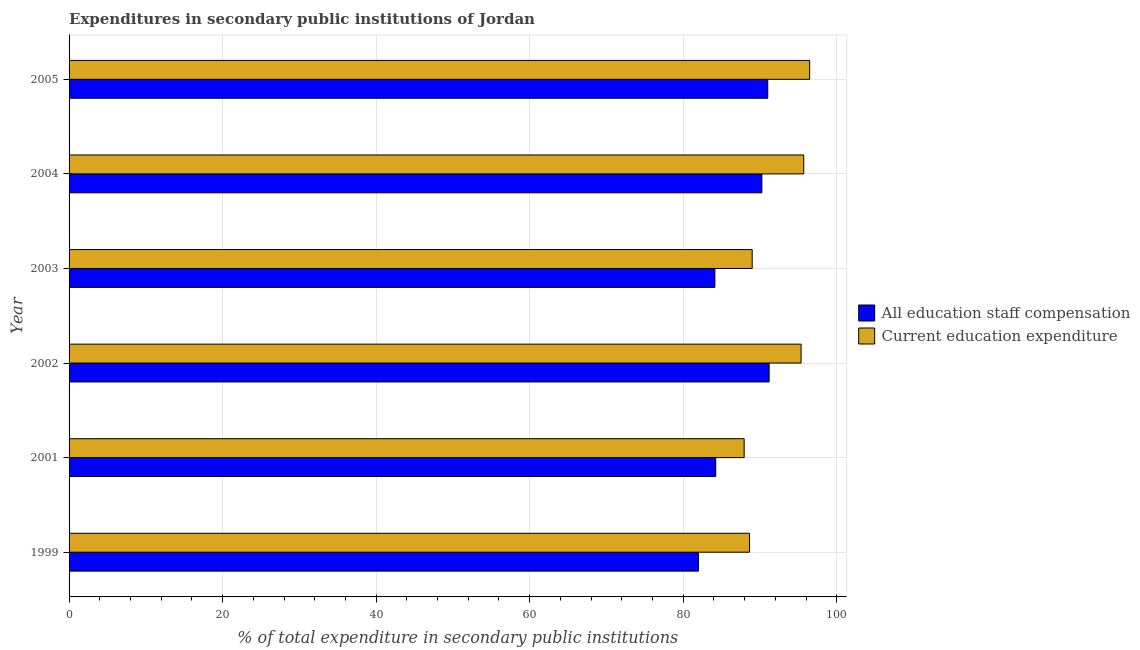How many different coloured bars are there?
Make the answer very short. 2. Are the number of bars on each tick of the Y-axis equal?
Provide a short and direct response. Yes. How many bars are there on the 3rd tick from the bottom?
Offer a very short reply. 2. What is the label of the 1st group of bars from the top?
Ensure brevity in your answer.  2005. In how many cases, is the number of bars for a given year not equal to the number of legend labels?
Offer a terse response. 0. What is the expenditure in staff compensation in 2001?
Your answer should be very brief. 84.24. Across all years, what is the maximum expenditure in staff compensation?
Offer a very short reply. 91.19. Across all years, what is the minimum expenditure in staff compensation?
Offer a very short reply. 81.99. In which year was the expenditure in education minimum?
Make the answer very short. 2001. What is the total expenditure in education in the graph?
Your response must be concise. 553.09. What is the difference between the expenditure in education in 2002 and that in 2003?
Your response must be concise. 6.37. What is the difference between the expenditure in education in 2003 and the expenditure in staff compensation in 2001?
Keep it short and to the point. 4.75. What is the average expenditure in staff compensation per year?
Make the answer very short. 87.13. In the year 2002, what is the difference between the expenditure in education and expenditure in staff compensation?
Your answer should be very brief. 4.16. In how many years, is the expenditure in staff compensation greater than 64 %?
Your response must be concise. 6. What is the ratio of the expenditure in education in 1999 to that in 2003?
Provide a short and direct response. 1. Is the expenditure in education in 2001 less than that in 2002?
Offer a terse response. Yes. What is the difference between the highest and the second highest expenditure in staff compensation?
Ensure brevity in your answer.  0.18. What is the difference between the highest and the lowest expenditure in education?
Offer a very short reply. 8.53. Is the sum of the expenditure in staff compensation in 1999 and 2005 greater than the maximum expenditure in education across all years?
Provide a short and direct response. Yes. What does the 2nd bar from the top in 2002 represents?
Keep it short and to the point. All education staff compensation. What does the 2nd bar from the bottom in 2004 represents?
Provide a short and direct response. Current education expenditure. How many bars are there?
Provide a short and direct response. 12. What is the difference between two consecutive major ticks on the X-axis?
Ensure brevity in your answer.  20. Are the values on the major ticks of X-axis written in scientific E-notation?
Ensure brevity in your answer.  No. Does the graph contain grids?
Your answer should be very brief. Yes. Where does the legend appear in the graph?
Offer a very short reply. Center right. How are the legend labels stacked?
Offer a terse response. Vertical. What is the title of the graph?
Provide a short and direct response. Expenditures in secondary public institutions of Jordan. What is the label or title of the X-axis?
Offer a terse response. % of total expenditure in secondary public institutions. What is the % of total expenditure in secondary public institutions in All education staff compensation in 1999?
Your response must be concise. 81.99. What is the % of total expenditure in secondary public institutions in Current education expenditure in 1999?
Keep it short and to the point. 88.64. What is the % of total expenditure in secondary public institutions in All education staff compensation in 2001?
Make the answer very short. 84.24. What is the % of total expenditure in secondary public institutions in Current education expenditure in 2001?
Keep it short and to the point. 87.94. What is the % of total expenditure in secondary public institutions of All education staff compensation in 2002?
Make the answer very short. 91.19. What is the % of total expenditure in secondary public institutions of Current education expenditure in 2002?
Provide a short and direct response. 95.35. What is the % of total expenditure in secondary public institutions in All education staff compensation in 2003?
Offer a very short reply. 84.13. What is the % of total expenditure in secondary public institutions of Current education expenditure in 2003?
Your answer should be compact. 88.98. What is the % of total expenditure in secondary public institutions of All education staff compensation in 2004?
Give a very brief answer. 90.25. What is the % of total expenditure in secondary public institutions in Current education expenditure in 2004?
Your answer should be very brief. 95.7. What is the % of total expenditure in secondary public institutions in All education staff compensation in 2005?
Your response must be concise. 91.01. What is the % of total expenditure in secondary public institutions of Current education expenditure in 2005?
Make the answer very short. 96.47. Across all years, what is the maximum % of total expenditure in secondary public institutions in All education staff compensation?
Keep it short and to the point. 91.19. Across all years, what is the maximum % of total expenditure in secondary public institutions in Current education expenditure?
Keep it short and to the point. 96.47. Across all years, what is the minimum % of total expenditure in secondary public institutions in All education staff compensation?
Your answer should be compact. 81.99. Across all years, what is the minimum % of total expenditure in secondary public institutions in Current education expenditure?
Provide a succinct answer. 87.94. What is the total % of total expenditure in secondary public institutions of All education staff compensation in the graph?
Provide a succinct answer. 522.8. What is the total % of total expenditure in secondary public institutions of Current education expenditure in the graph?
Keep it short and to the point. 553.09. What is the difference between the % of total expenditure in secondary public institutions of All education staff compensation in 1999 and that in 2001?
Ensure brevity in your answer.  -2.25. What is the difference between the % of total expenditure in secondary public institutions in Current education expenditure in 1999 and that in 2001?
Make the answer very short. 0.7. What is the difference between the % of total expenditure in secondary public institutions in All education staff compensation in 1999 and that in 2002?
Keep it short and to the point. -9.21. What is the difference between the % of total expenditure in secondary public institutions in Current education expenditure in 1999 and that in 2002?
Make the answer very short. -6.71. What is the difference between the % of total expenditure in secondary public institutions in All education staff compensation in 1999 and that in 2003?
Your answer should be very brief. -2.14. What is the difference between the % of total expenditure in secondary public institutions in Current education expenditure in 1999 and that in 2003?
Offer a terse response. -0.34. What is the difference between the % of total expenditure in secondary public institutions of All education staff compensation in 1999 and that in 2004?
Provide a short and direct response. -8.26. What is the difference between the % of total expenditure in secondary public institutions in Current education expenditure in 1999 and that in 2004?
Give a very brief answer. -7.06. What is the difference between the % of total expenditure in secondary public institutions of All education staff compensation in 1999 and that in 2005?
Ensure brevity in your answer.  -9.03. What is the difference between the % of total expenditure in secondary public institutions in Current education expenditure in 1999 and that in 2005?
Provide a short and direct response. -7.83. What is the difference between the % of total expenditure in secondary public institutions in All education staff compensation in 2001 and that in 2002?
Your answer should be very brief. -6.96. What is the difference between the % of total expenditure in secondary public institutions in Current education expenditure in 2001 and that in 2002?
Offer a terse response. -7.42. What is the difference between the % of total expenditure in secondary public institutions of All education staff compensation in 2001 and that in 2003?
Ensure brevity in your answer.  0.11. What is the difference between the % of total expenditure in secondary public institutions in Current education expenditure in 2001 and that in 2003?
Your answer should be very brief. -1.05. What is the difference between the % of total expenditure in secondary public institutions of All education staff compensation in 2001 and that in 2004?
Keep it short and to the point. -6.01. What is the difference between the % of total expenditure in secondary public institutions of Current education expenditure in 2001 and that in 2004?
Provide a succinct answer. -7.76. What is the difference between the % of total expenditure in secondary public institutions in All education staff compensation in 2001 and that in 2005?
Your answer should be very brief. -6.78. What is the difference between the % of total expenditure in secondary public institutions in Current education expenditure in 2001 and that in 2005?
Provide a short and direct response. -8.53. What is the difference between the % of total expenditure in secondary public institutions of All education staff compensation in 2002 and that in 2003?
Offer a very short reply. 7.07. What is the difference between the % of total expenditure in secondary public institutions in Current education expenditure in 2002 and that in 2003?
Offer a terse response. 6.37. What is the difference between the % of total expenditure in secondary public institutions of All education staff compensation in 2002 and that in 2004?
Your response must be concise. 0.95. What is the difference between the % of total expenditure in secondary public institutions in Current education expenditure in 2002 and that in 2004?
Keep it short and to the point. -0.35. What is the difference between the % of total expenditure in secondary public institutions of All education staff compensation in 2002 and that in 2005?
Offer a terse response. 0.18. What is the difference between the % of total expenditure in secondary public institutions of Current education expenditure in 2002 and that in 2005?
Provide a succinct answer. -1.12. What is the difference between the % of total expenditure in secondary public institutions of All education staff compensation in 2003 and that in 2004?
Offer a terse response. -6.12. What is the difference between the % of total expenditure in secondary public institutions of Current education expenditure in 2003 and that in 2004?
Offer a terse response. -6.72. What is the difference between the % of total expenditure in secondary public institutions in All education staff compensation in 2003 and that in 2005?
Offer a very short reply. -6.89. What is the difference between the % of total expenditure in secondary public institutions in Current education expenditure in 2003 and that in 2005?
Give a very brief answer. -7.49. What is the difference between the % of total expenditure in secondary public institutions of All education staff compensation in 2004 and that in 2005?
Your answer should be very brief. -0.77. What is the difference between the % of total expenditure in secondary public institutions in Current education expenditure in 2004 and that in 2005?
Keep it short and to the point. -0.77. What is the difference between the % of total expenditure in secondary public institutions in All education staff compensation in 1999 and the % of total expenditure in secondary public institutions in Current education expenditure in 2001?
Make the answer very short. -5.95. What is the difference between the % of total expenditure in secondary public institutions in All education staff compensation in 1999 and the % of total expenditure in secondary public institutions in Current education expenditure in 2002?
Provide a succinct answer. -13.37. What is the difference between the % of total expenditure in secondary public institutions of All education staff compensation in 1999 and the % of total expenditure in secondary public institutions of Current education expenditure in 2003?
Give a very brief answer. -7. What is the difference between the % of total expenditure in secondary public institutions of All education staff compensation in 1999 and the % of total expenditure in secondary public institutions of Current education expenditure in 2004?
Offer a terse response. -13.71. What is the difference between the % of total expenditure in secondary public institutions of All education staff compensation in 1999 and the % of total expenditure in secondary public institutions of Current education expenditure in 2005?
Your response must be concise. -14.48. What is the difference between the % of total expenditure in secondary public institutions in All education staff compensation in 2001 and the % of total expenditure in secondary public institutions in Current education expenditure in 2002?
Provide a succinct answer. -11.12. What is the difference between the % of total expenditure in secondary public institutions of All education staff compensation in 2001 and the % of total expenditure in secondary public institutions of Current education expenditure in 2003?
Make the answer very short. -4.75. What is the difference between the % of total expenditure in secondary public institutions of All education staff compensation in 2001 and the % of total expenditure in secondary public institutions of Current education expenditure in 2004?
Ensure brevity in your answer.  -11.46. What is the difference between the % of total expenditure in secondary public institutions of All education staff compensation in 2001 and the % of total expenditure in secondary public institutions of Current education expenditure in 2005?
Give a very brief answer. -12.23. What is the difference between the % of total expenditure in secondary public institutions in All education staff compensation in 2002 and the % of total expenditure in secondary public institutions in Current education expenditure in 2003?
Keep it short and to the point. 2.21. What is the difference between the % of total expenditure in secondary public institutions in All education staff compensation in 2002 and the % of total expenditure in secondary public institutions in Current education expenditure in 2004?
Ensure brevity in your answer.  -4.51. What is the difference between the % of total expenditure in secondary public institutions of All education staff compensation in 2002 and the % of total expenditure in secondary public institutions of Current education expenditure in 2005?
Your answer should be compact. -5.28. What is the difference between the % of total expenditure in secondary public institutions in All education staff compensation in 2003 and the % of total expenditure in secondary public institutions in Current education expenditure in 2004?
Your answer should be very brief. -11.58. What is the difference between the % of total expenditure in secondary public institutions in All education staff compensation in 2003 and the % of total expenditure in secondary public institutions in Current education expenditure in 2005?
Provide a succinct answer. -12.34. What is the difference between the % of total expenditure in secondary public institutions of All education staff compensation in 2004 and the % of total expenditure in secondary public institutions of Current education expenditure in 2005?
Your answer should be very brief. -6.22. What is the average % of total expenditure in secondary public institutions in All education staff compensation per year?
Offer a terse response. 87.13. What is the average % of total expenditure in secondary public institutions of Current education expenditure per year?
Provide a short and direct response. 92.18. In the year 1999, what is the difference between the % of total expenditure in secondary public institutions of All education staff compensation and % of total expenditure in secondary public institutions of Current education expenditure?
Ensure brevity in your answer.  -6.65. In the year 2001, what is the difference between the % of total expenditure in secondary public institutions of All education staff compensation and % of total expenditure in secondary public institutions of Current education expenditure?
Give a very brief answer. -3.7. In the year 2002, what is the difference between the % of total expenditure in secondary public institutions of All education staff compensation and % of total expenditure in secondary public institutions of Current education expenditure?
Your answer should be compact. -4.16. In the year 2003, what is the difference between the % of total expenditure in secondary public institutions of All education staff compensation and % of total expenditure in secondary public institutions of Current education expenditure?
Provide a short and direct response. -4.86. In the year 2004, what is the difference between the % of total expenditure in secondary public institutions of All education staff compensation and % of total expenditure in secondary public institutions of Current education expenditure?
Make the answer very short. -5.45. In the year 2005, what is the difference between the % of total expenditure in secondary public institutions in All education staff compensation and % of total expenditure in secondary public institutions in Current education expenditure?
Your response must be concise. -5.46. What is the ratio of the % of total expenditure in secondary public institutions in All education staff compensation in 1999 to that in 2001?
Provide a short and direct response. 0.97. What is the ratio of the % of total expenditure in secondary public institutions in All education staff compensation in 1999 to that in 2002?
Make the answer very short. 0.9. What is the ratio of the % of total expenditure in secondary public institutions of Current education expenditure in 1999 to that in 2002?
Give a very brief answer. 0.93. What is the ratio of the % of total expenditure in secondary public institutions of All education staff compensation in 1999 to that in 2003?
Your answer should be compact. 0.97. What is the ratio of the % of total expenditure in secondary public institutions in All education staff compensation in 1999 to that in 2004?
Give a very brief answer. 0.91. What is the ratio of the % of total expenditure in secondary public institutions of Current education expenditure in 1999 to that in 2004?
Your answer should be very brief. 0.93. What is the ratio of the % of total expenditure in secondary public institutions in All education staff compensation in 1999 to that in 2005?
Ensure brevity in your answer.  0.9. What is the ratio of the % of total expenditure in secondary public institutions of Current education expenditure in 1999 to that in 2005?
Your answer should be compact. 0.92. What is the ratio of the % of total expenditure in secondary public institutions of All education staff compensation in 2001 to that in 2002?
Provide a short and direct response. 0.92. What is the ratio of the % of total expenditure in secondary public institutions of Current education expenditure in 2001 to that in 2002?
Offer a very short reply. 0.92. What is the ratio of the % of total expenditure in secondary public institutions of All education staff compensation in 2001 to that in 2003?
Make the answer very short. 1. What is the ratio of the % of total expenditure in secondary public institutions of Current education expenditure in 2001 to that in 2003?
Give a very brief answer. 0.99. What is the ratio of the % of total expenditure in secondary public institutions of All education staff compensation in 2001 to that in 2004?
Your answer should be compact. 0.93. What is the ratio of the % of total expenditure in secondary public institutions of Current education expenditure in 2001 to that in 2004?
Provide a succinct answer. 0.92. What is the ratio of the % of total expenditure in secondary public institutions in All education staff compensation in 2001 to that in 2005?
Give a very brief answer. 0.93. What is the ratio of the % of total expenditure in secondary public institutions in Current education expenditure in 2001 to that in 2005?
Your answer should be compact. 0.91. What is the ratio of the % of total expenditure in secondary public institutions in All education staff compensation in 2002 to that in 2003?
Ensure brevity in your answer.  1.08. What is the ratio of the % of total expenditure in secondary public institutions in Current education expenditure in 2002 to that in 2003?
Your answer should be very brief. 1.07. What is the ratio of the % of total expenditure in secondary public institutions in All education staff compensation in 2002 to that in 2004?
Keep it short and to the point. 1.01. What is the ratio of the % of total expenditure in secondary public institutions in Current education expenditure in 2002 to that in 2005?
Your answer should be very brief. 0.99. What is the ratio of the % of total expenditure in secondary public institutions of All education staff compensation in 2003 to that in 2004?
Provide a short and direct response. 0.93. What is the ratio of the % of total expenditure in secondary public institutions of Current education expenditure in 2003 to that in 2004?
Offer a very short reply. 0.93. What is the ratio of the % of total expenditure in secondary public institutions in All education staff compensation in 2003 to that in 2005?
Ensure brevity in your answer.  0.92. What is the ratio of the % of total expenditure in secondary public institutions in Current education expenditure in 2003 to that in 2005?
Your answer should be compact. 0.92. What is the ratio of the % of total expenditure in secondary public institutions of All education staff compensation in 2004 to that in 2005?
Keep it short and to the point. 0.99. What is the ratio of the % of total expenditure in secondary public institutions in Current education expenditure in 2004 to that in 2005?
Keep it short and to the point. 0.99. What is the difference between the highest and the second highest % of total expenditure in secondary public institutions of All education staff compensation?
Make the answer very short. 0.18. What is the difference between the highest and the second highest % of total expenditure in secondary public institutions of Current education expenditure?
Make the answer very short. 0.77. What is the difference between the highest and the lowest % of total expenditure in secondary public institutions in All education staff compensation?
Ensure brevity in your answer.  9.21. What is the difference between the highest and the lowest % of total expenditure in secondary public institutions in Current education expenditure?
Offer a terse response. 8.53. 